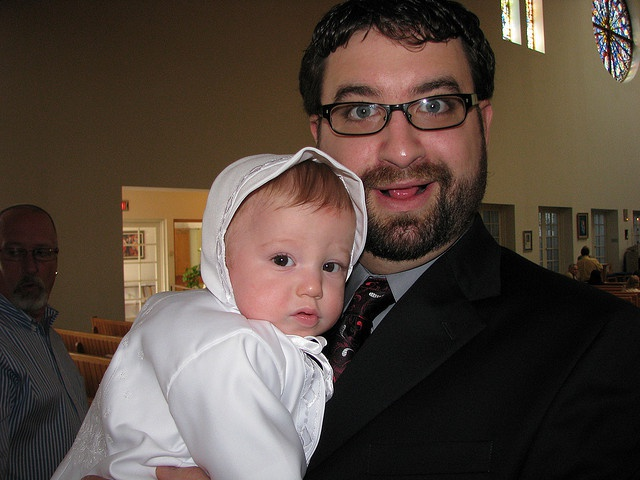Describe the objects in this image and their specific colors. I can see people in black, brown, maroon, and gray tones, people in black, darkgray, lightgray, gray, and salmon tones, people in black tones, tie in black, maroon, gray, and darkgray tones, and chair in black, maroon, and brown tones in this image. 